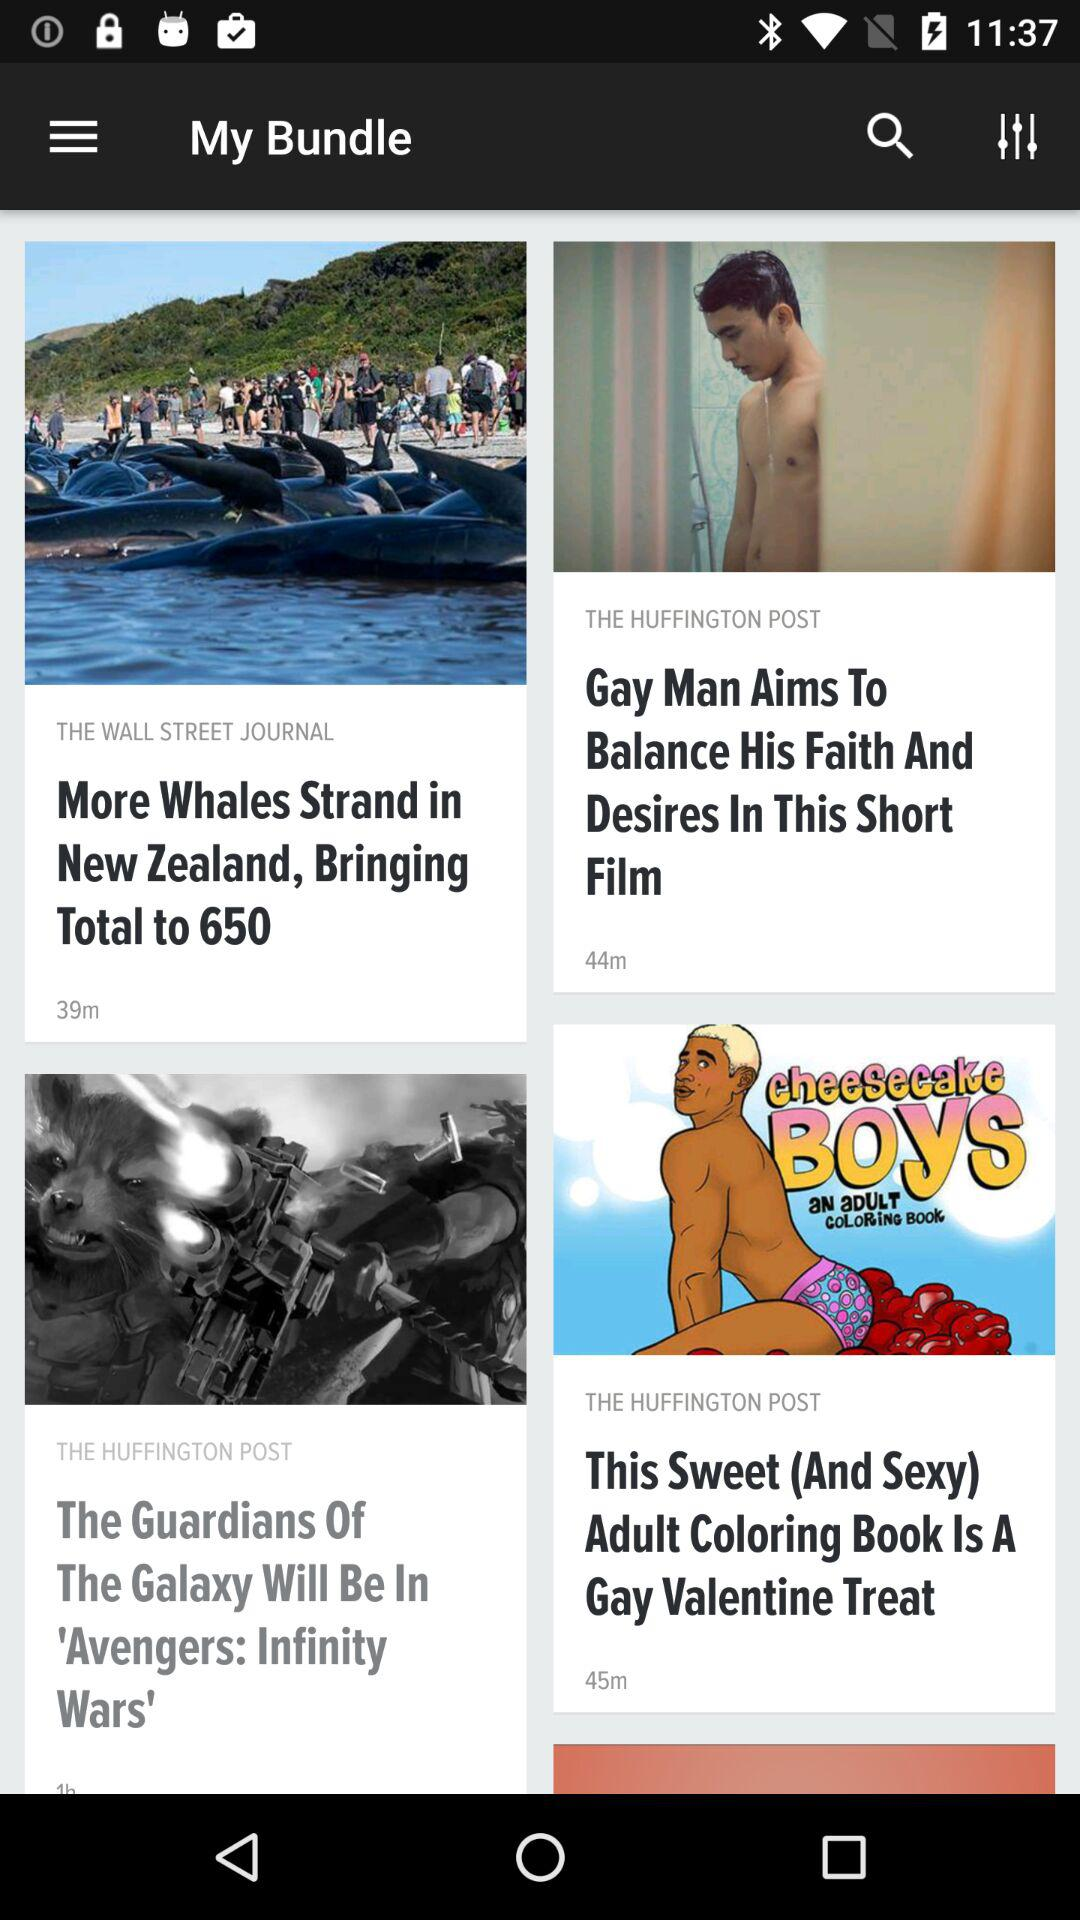How many more minutes are there in the second video than the first?
Answer the question using a single word or phrase. 5 